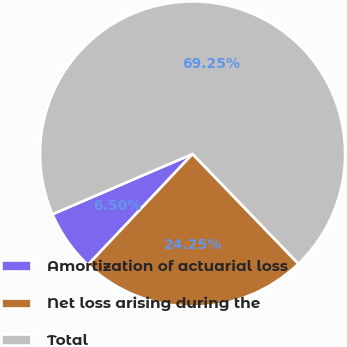Convert chart. <chart><loc_0><loc_0><loc_500><loc_500><pie_chart><fcel>Amortization of actuarial loss<fcel>Net loss arising during the<fcel>Total<nl><fcel>6.5%<fcel>24.25%<fcel>69.26%<nl></chart> 